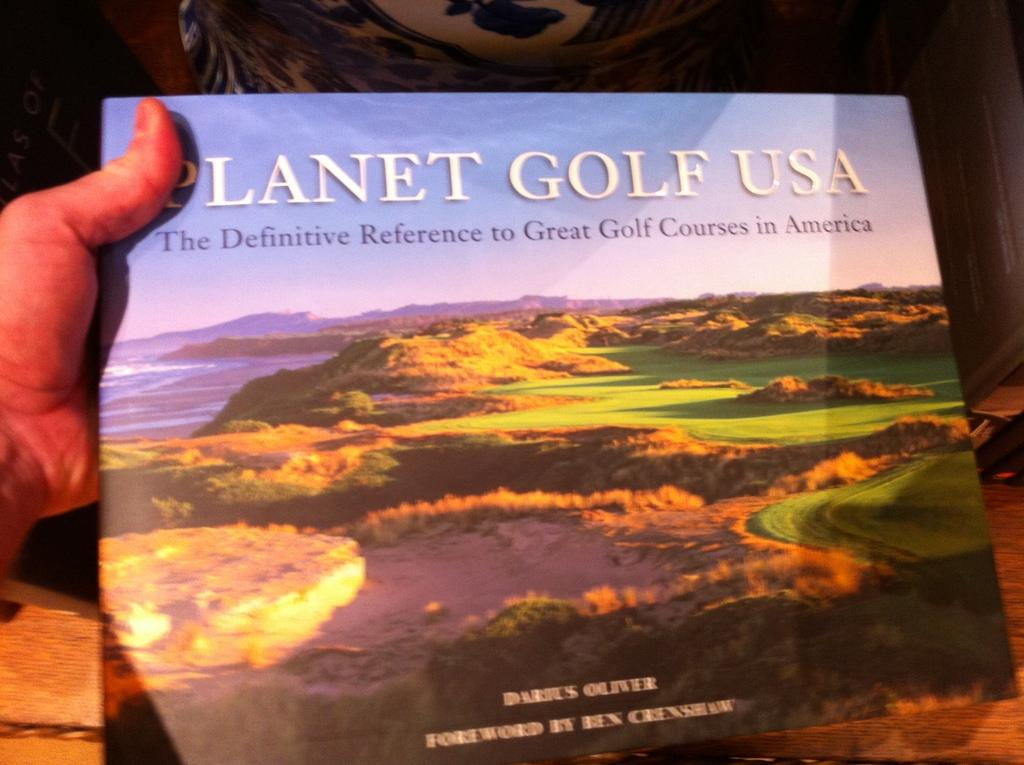<image>
Provide a brief description of the given image. Planet Golf USA was written by Darius Oliver. 